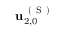Convert formula to latex. <formula><loc_0><loc_0><loc_500><loc_500>u _ { 2 , 0 } ^ { ( S ) }</formula> 